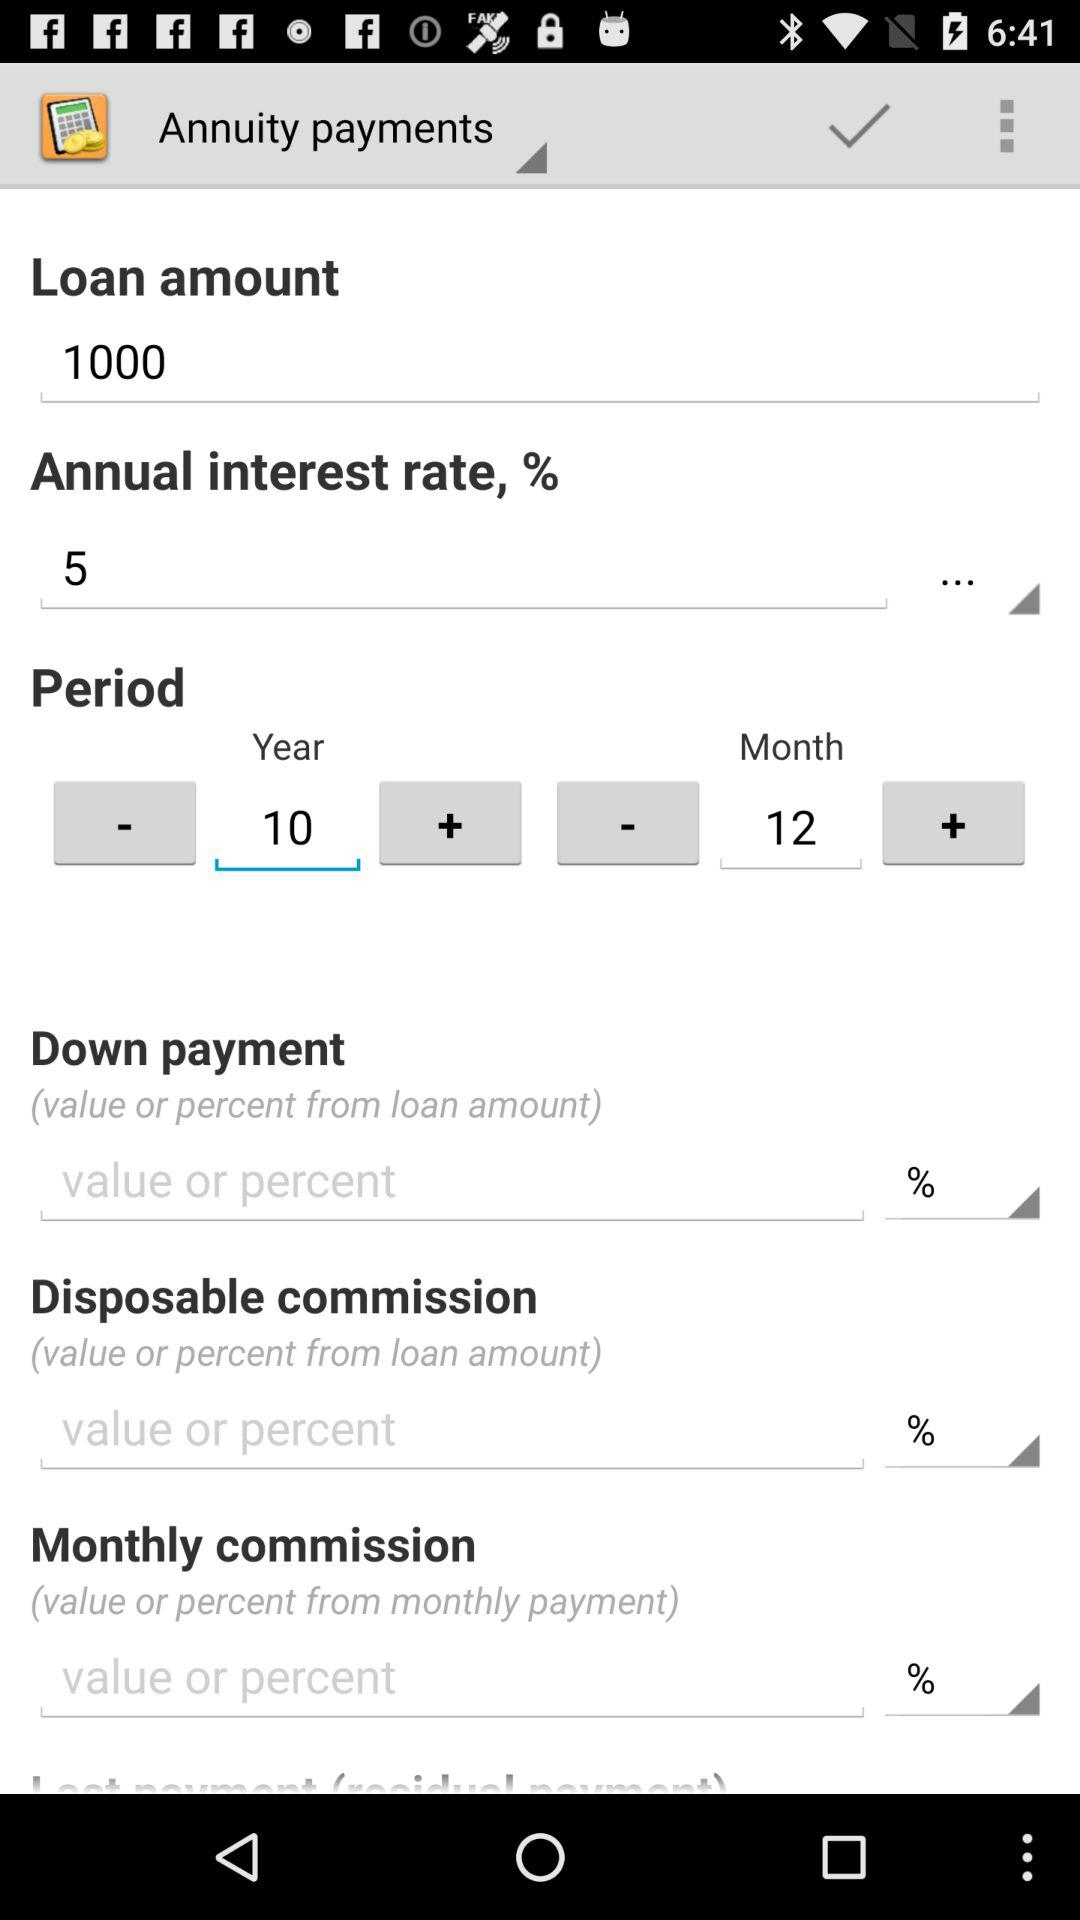What is the loan amount? The loan amount is 1000. 